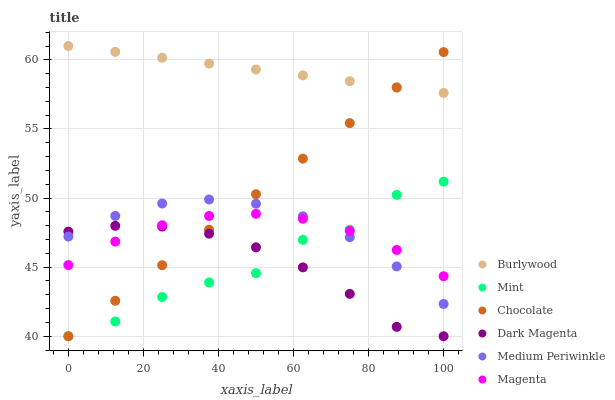Does Dark Magenta have the minimum area under the curve?
Answer yes or no. Yes. Does Burlywood have the maximum area under the curve?
Answer yes or no. Yes. Does Medium Periwinkle have the minimum area under the curve?
Answer yes or no. No. Does Medium Periwinkle have the maximum area under the curve?
Answer yes or no. No. Is Chocolate the smoothest?
Answer yes or no. Yes. Is Mint the roughest?
Answer yes or no. Yes. Is Burlywood the smoothest?
Answer yes or no. No. Is Burlywood the roughest?
Answer yes or no. No. Does Dark Magenta have the lowest value?
Answer yes or no. Yes. Does Medium Periwinkle have the lowest value?
Answer yes or no. No. Does Burlywood have the highest value?
Answer yes or no. Yes. Does Medium Periwinkle have the highest value?
Answer yes or no. No. Is Magenta less than Burlywood?
Answer yes or no. Yes. Is Burlywood greater than Medium Periwinkle?
Answer yes or no. Yes. Does Medium Periwinkle intersect Chocolate?
Answer yes or no. Yes. Is Medium Periwinkle less than Chocolate?
Answer yes or no. No. Is Medium Periwinkle greater than Chocolate?
Answer yes or no. No. Does Magenta intersect Burlywood?
Answer yes or no. No. 